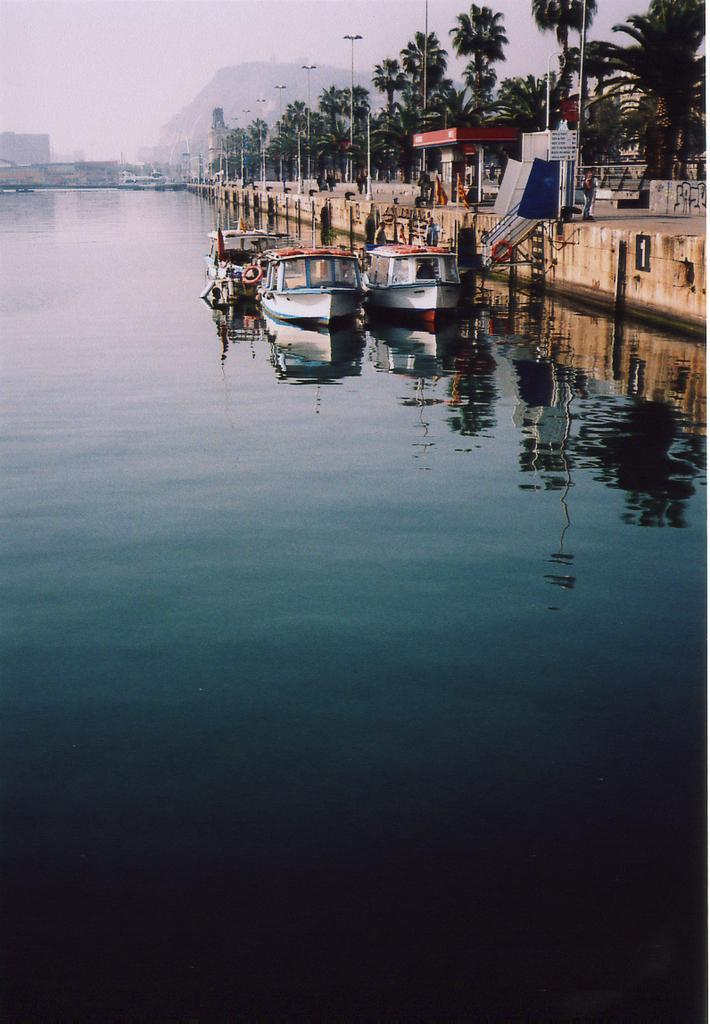What is located in the middle of the image? There are boats in the water in the middle of the image. What type of vegetation is on the right side of the image? There are trees on the right side of the image. What is visible at the top of the image? The sky is visible at the top of the image. What type of song can be heard coming from the boats in the image? There is no indication in the image that any song is being played or heard from the boats. --- 